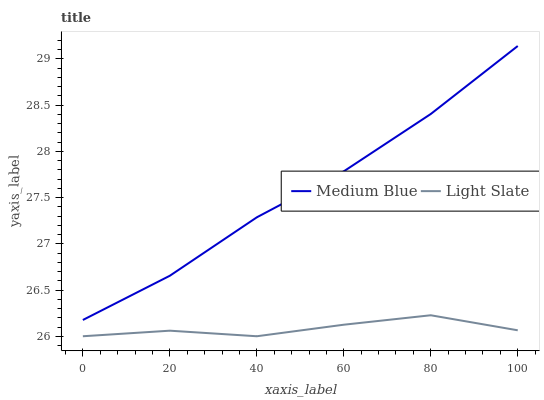Does Light Slate have the minimum area under the curve?
Answer yes or no. Yes. Does Medium Blue have the maximum area under the curve?
Answer yes or no. Yes. Does Medium Blue have the minimum area under the curve?
Answer yes or no. No. Is Medium Blue the smoothest?
Answer yes or no. Yes. Is Light Slate the roughest?
Answer yes or no. Yes. Is Medium Blue the roughest?
Answer yes or no. No. Does Light Slate have the lowest value?
Answer yes or no. Yes. Does Medium Blue have the lowest value?
Answer yes or no. No. Does Medium Blue have the highest value?
Answer yes or no. Yes. Is Light Slate less than Medium Blue?
Answer yes or no. Yes. Is Medium Blue greater than Light Slate?
Answer yes or no. Yes. Does Light Slate intersect Medium Blue?
Answer yes or no. No. 